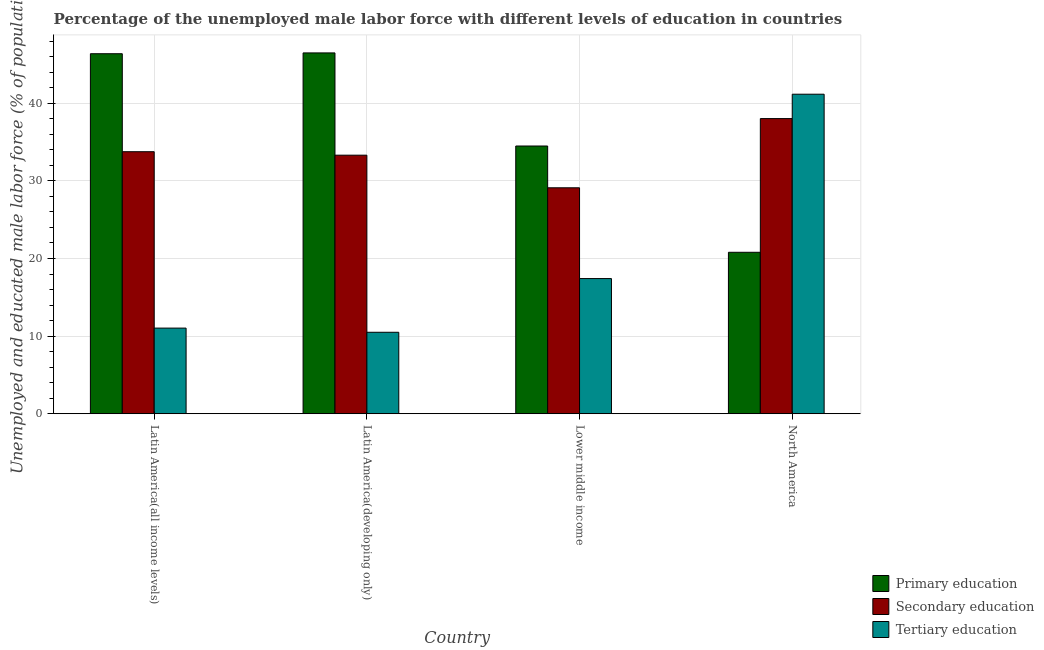How many different coloured bars are there?
Ensure brevity in your answer.  3. How many groups of bars are there?
Provide a succinct answer. 4. Are the number of bars per tick equal to the number of legend labels?
Ensure brevity in your answer.  Yes. Are the number of bars on each tick of the X-axis equal?
Keep it short and to the point. Yes. How many bars are there on the 4th tick from the left?
Make the answer very short. 3. What is the label of the 3rd group of bars from the left?
Keep it short and to the point. Lower middle income. In how many cases, is the number of bars for a given country not equal to the number of legend labels?
Your response must be concise. 0. What is the percentage of male labor force who received primary education in Latin America(all income levels)?
Provide a succinct answer. 46.39. Across all countries, what is the maximum percentage of male labor force who received primary education?
Ensure brevity in your answer.  46.49. Across all countries, what is the minimum percentage of male labor force who received primary education?
Make the answer very short. 20.8. In which country was the percentage of male labor force who received tertiary education maximum?
Your response must be concise. North America. In which country was the percentage of male labor force who received tertiary education minimum?
Your answer should be compact. Latin America(developing only). What is the total percentage of male labor force who received primary education in the graph?
Ensure brevity in your answer.  148.18. What is the difference between the percentage of male labor force who received primary education in Latin America(developing only) and that in Lower middle income?
Your answer should be compact. 11.99. What is the difference between the percentage of male labor force who received secondary education in Latin America(all income levels) and the percentage of male labor force who received tertiary education in Latin America(developing only)?
Your response must be concise. 23.26. What is the average percentage of male labor force who received primary education per country?
Provide a succinct answer. 37.04. What is the difference between the percentage of male labor force who received tertiary education and percentage of male labor force who received secondary education in Latin America(developing only)?
Offer a very short reply. -22.82. What is the ratio of the percentage of male labor force who received secondary education in Latin America(all income levels) to that in Lower middle income?
Give a very brief answer. 1.16. Is the percentage of male labor force who received secondary education in Latin America(developing only) less than that in North America?
Ensure brevity in your answer.  Yes. What is the difference between the highest and the second highest percentage of male labor force who received primary education?
Provide a short and direct response. 0.1. What is the difference between the highest and the lowest percentage of male labor force who received tertiary education?
Offer a terse response. 30.67. In how many countries, is the percentage of male labor force who received secondary education greater than the average percentage of male labor force who received secondary education taken over all countries?
Your answer should be compact. 2. Is the sum of the percentage of male labor force who received tertiary education in Latin America(all income levels) and Latin America(developing only) greater than the maximum percentage of male labor force who received secondary education across all countries?
Your response must be concise. No. What does the 2nd bar from the left in North America represents?
Offer a very short reply. Secondary education. What does the 1st bar from the right in Latin America(developing only) represents?
Provide a short and direct response. Tertiary education. Is it the case that in every country, the sum of the percentage of male labor force who received primary education and percentage of male labor force who received secondary education is greater than the percentage of male labor force who received tertiary education?
Your answer should be very brief. Yes. How many countries are there in the graph?
Offer a terse response. 4. What is the difference between two consecutive major ticks on the Y-axis?
Provide a short and direct response. 10. Does the graph contain any zero values?
Your answer should be very brief. No. Does the graph contain grids?
Offer a very short reply. Yes. Where does the legend appear in the graph?
Keep it short and to the point. Bottom right. How are the legend labels stacked?
Keep it short and to the point. Vertical. What is the title of the graph?
Make the answer very short. Percentage of the unemployed male labor force with different levels of education in countries. What is the label or title of the X-axis?
Offer a terse response. Country. What is the label or title of the Y-axis?
Make the answer very short. Unemployed and educated male labor force (% of population). What is the Unemployed and educated male labor force (% of population) of Primary education in Latin America(all income levels)?
Your answer should be very brief. 46.39. What is the Unemployed and educated male labor force (% of population) of Secondary education in Latin America(all income levels)?
Keep it short and to the point. 33.76. What is the Unemployed and educated male labor force (% of population) of Tertiary education in Latin America(all income levels)?
Give a very brief answer. 11.03. What is the Unemployed and educated male labor force (% of population) in Primary education in Latin America(developing only)?
Offer a terse response. 46.49. What is the Unemployed and educated male labor force (% of population) of Secondary education in Latin America(developing only)?
Offer a terse response. 33.31. What is the Unemployed and educated male labor force (% of population) of Tertiary education in Latin America(developing only)?
Provide a succinct answer. 10.5. What is the Unemployed and educated male labor force (% of population) in Primary education in Lower middle income?
Make the answer very short. 34.5. What is the Unemployed and educated male labor force (% of population) in Secondary education in Lower middle income?
Offer a very short reply. 29.11. What is the Unemployed and educated male labor force (% of population) in Tertiary education in Lower middle income?
Provide a succinct answer. 17.42. What is the Unemployed and educated male labor force (% of population) in Primary education in North America?
Your response must be concise. 20.8. What is the Unemployed and educated male labor force (% of population) of Secondary education in North America?
Your answer should be compact. 38.03. What is the Unemployed and educated male labor force (% of population) of Tertiary education in North America?
Give a very brief answer. 41.17. Across all countries, what is the maximum Unemployed and educated male labor force (% of population) of Primary education?
Ensure brevity in your answer.  46.49. Across all countries, what is the maximum Unemployed and educated male labor force (% of population) of Secondary education?
Provide a short and direct response. 38.03. Across all countries, what is the maximum Unemployed and educated male labor force (% of population) in Tertiary education?
Keep it short and to the point. 41.17. Across all countries, what is the minimum Unemployed and educated male labor force (% of population) in Primary education?
Provide a succinct answer. 20.8. Across all countries, what is the minimum Unemployed and educated male labor force (% of population) in Secondary education?
Provide a short and direct response. 29.11. Across all countries, what is the minimum Unemployed and educated male labor force (% of population) in Tertiary education?
Provide a succinct answer. 10.5. What is the total Unemployed and educated male labor force (% of population) of Primary education in the graph?
Give a very brief answer. 148.18. What is the total Unemployed and educated male labor force (% of population) of Secondary education in the graph?
Give a very brief answer. 134.22. What is the total Unemployed and educated male labor force (% of population) of Tertiary education in the graph?
Your answer should be compact. 80.12. What is the difference between the Unemployed and educated male labor force (% of population) of Primary education in Latin America(all income levels) and that in Latin America(developing only)?
Ensure brevity in your answer.  -0.1. What is the difference between the Unemployed and educated male labor force (% of population) of Secondary education in Latin America(all income levels) and that in Latin America(developing only)?
Provide a succinct answer. 0.45. What is the difference between the Unemployed and educated male labor force (% of population) of Tertiary education in Latin America(all income levels) and that in Latin America(developing only)?
Offer a terse response. 0.54. What is the difference between the Unemployed and educated male labor force (% of population) of Primary education in Latin America(all income levels) and that in Lower middle income?
Give a very brief answer. 11.89. What is the difference between the Unemployed and educated male labor force (% of population) in Secondary education in Latin America(all income levels) and that in Lower middle income?
Keep it short and to the point. 4.65. What is the difference between the Unemployed and educated male labor force (% of population) of Tertiary education in Latin America(all income levels) and that in Lower middle income?
Your response must be concise. -6.38. What is the difference between the Unemployed and educated male labor force (% of population) of Primary education in Latin America(all income levels) and that in North America?
Your answer should be very brief. 25.58. What is the difference between the Unemployed and educated male labor force (% of population) in Secondary education in Latin America(all income levels) and that in North America?
Offer a very short reply. -4.27. What is the difference between the Unemployed and educated male labor force (% of population) in Tertiary education in Latin America(all income levels) and that in North America?
Offer a terse response. -30.13. What is the difference between the Unemployed and educated male labor force (% of population) in Primary education in Latin America(developing only) and that in Lower middle income?
Offer a terse response. 11.99. What is the difference between the Unemployed and educated male labor force (% of population) of Secondary education in Latin America(developing only) and that in Lower middle income?
Keep it short and to the point. 4.2. What is the difference between the Unemployed and educated male labor force (% of population) in Tertiary education in Latin America(developing only) and that in Lower middle income?
Ensure brevity in your answer.  -6.92. What is the difference between the Unemployed and educated male labor force (% of population) of Primary education in Latin America(developing only) and that in North America?
Provide a short and direct response. 25.69. What is the difference between the Unemployed and educated male labor force (% of population) in Secondary education in Latin America(developing only) and that in North America?
Make the answer very short. -4.71. What is the difference between the Unemployed and educated male labor force (% of population) of Tertiary education in Latin America(developing only) and that in North America?
Your answer should be very brief. -30.67. What is the difference between the Unemployed and educated male labor force (% of population) in Primary education in Lower middle income and that in North America?
Your answer should be compact. 13.69. What is the difference between the Unemployed and educated male labor force (% of population) in Secondary education in Lower middle income and that in North America?
Your answer should be very brief. -8.92. What is the difference between the Unemployed and educated male labor force (% of population) in Tertiary education in Lower middle income and that in North America?
Provide a short and direct response. -23.75. What is the difference between the Unemployed and educated male labor force (% of population) of Primary education in Latin America(all income levels) and the Unemployed and educated male labor force (% of population) of Secondary education in Latin America(developing only)?
Offer a terse response. 13.07. What is the difference between the Unemployed and educated male labor force (% of population) of Primary education in Latin America(all income levels) and the Unemployed and educated male labor force (% of population) of Tertiary education in Latin America(developing only)?
Your answer should be very brief. 35.89. What is the difference between the Unemployed and educated male labor force (% of population) in Secondary education in Latin America(all income levels) and the Unemployed and educated male labor force (% of population) in Tertiary education in Latin America(developing only)?
Keep it short and to the point. 23.26. What is the difference between the Unemployed and educated male labor force (% of population) in Primary education in Latin America(all income levels) and the Unemployed and educated male labor force (% of population) in Secondary education in Lower middle income?
Give a very brief answer. 17.27. What is the difference between the Unemployed and educated male labor force (% of population) of Primary education in Latin America(all income levels) and the Unemployed and educated male labor force (% of population) of Tertiary education in Lower middle income?
Your response must be concise. 28.97. What is the difference between the Unemployed and educated male labor force (% of population) of Secondary education in Latin America(all income levels) and the Unemployed and educated male labor force (% of population) of Tertiary education in Lower middle income?
Make the answer very short. 16.34. What is the difference between the Unemployed and educated male labor force (% of population) in Primary education in Latin America(all income levels) and the Unemployed and educated male labor force (% of population) in Secondary education in North America?
Your answer should be very brief. 8.36. What is the difference between the Unemployed and educated male labor force (% of population) of Primary education in Latin America(all income levels) and the Unemployed and educated male labor force (% of population) of Tertiary education in North America?
Offer a terse response. 5.22. What is the difference between the Unemployed and educated male labor force (% of population) of Secondary education in Latin America(all income levels) and the Unemployed and educated male labor force (% of population) of Tertiary education in North America?
Make the answer very short. -7.41. What is the difference between the Unemployed and educated male labor force (% of population) in Primary education in Latin America(developing only) and the Unemployed and educated male labor force (% of population) in Secondary education in Lower middle income?
Provide a succinct answer. 17.38. What is the difference between the Unemployed and educated male labor force (% of population) of Primary education in Latin America(developing only) and the Unemployed and educated male labor force (% of population) of Tertiary education in Lower middle income?
Provide a succinct answer. 29.07. What is the difference between the Unemployed and educated male labor force (% of population) in Secondary education in Latin America(developing only) and the Unemployed and educated male labor force (% of population) in Tertiary education in Lower middle income?
Give a very brief answer. 15.9. What is the difference between the Unemployed and educated male labor force (% of population) of Primary education in Latin America(developing only) and the Unemployed and educated male labor force (% of population) of Secondary education in North America?
Provide a succinct answer. 8.46. What is the difference between the Unemployed and educated male labor force (% of population) of Primary education in Latin America(developing only) and the Unemployed and educated male labor force (% of population) of Tertiary education in North America?
Provide a short and direct response. 5.32. What is the difference between the Unemployed and educated male labor force (% of population) in Secondary education in Latin America(developing only) and the Unemployed and educated male labor force (% of population) in Tertiary education in North America?
Offer a very short reply. -7.85. What is the difference between the Unemployed and educated male labor force (% of population) in Primary education in Lower middle income and the Unemployed and educated male labor force (% of population) in Secondary education in North America?
Make the answer very short. -3.53. What is the difference between the Unemployed and educated male labor force (% of population) of Primary education in Lower middle income and the Unemployed and educated male labor force (% of population) of Tertiary education in North America?
Provide a short and direct response. -6.67. What is the difference between the Unemployed and educated male labor force (% of population) of Secondary education in Lower middle income and the Unemployed and educated male labor force (% of population) of Tertiary education in North America?
Make the answer very short. -12.06. What is the average Unemployed and educated male labor force (% of population) of Primary education per country?
Offer a very short reply. 37.04. What is the average Unemployed and educated male labor force (% of population) of Secondary education per country?
Offer a terse response. 33.55. What is the average Unemployed and educated male labor force (% of population) in Tertiary education per country?
Give a very brief answer. 20.03. What is the difference between the Unemployed and educated male labor force (% of population) of Primary education and Unemployed and educated male labor force (% of population) of Secondary education in Latin America(all income levels)?
Give a very brief answer. 12.63. What is the difference between the Unemployed and educated male labor force (% of population) of Primary education and Unemployed and educated male labor force (% of population) of Tertiary education in Latin America(all income levels)?
Make the answer very short. 35.35. What is the difference between the Unemployed and educated male labor force (% of population) of Secondary education and Unemployed and educated male labor force (% of population) of Tertiary education in Latin America(all income levels)?
Give a very brief answer. 22.73. What is the difference between the Unemployed and educated male labor force (% of population) of Primary education and Unemployed and educated male labor force (% of population) of Secondary education in Latin America(developing only)?
Offer a very short reply. 13.18. What is the difference between the Unemployed and educated male labor force (% of population) of Primary education and Unemployed and educated male labor force (% of population) of Tertiary education in Latin America(developing only)?
Offer a very short reply. 35.99. What is the difference between the Unemployed and educated male labor force (% of population) in Secondary education and Unemployed and educated male labor force (% of population) in Tertiary education in Latin America(developing only)?
Provide a short and direct response. 22.82. What is the difference between the Unemployed and educated male labor force (% of population) of Primary education and Unemployed and educated male labor force (% of population) of Secondary education in Lower middle income?
Keep it short and to the point. 5.38. What is the difference between the Unemployed and educated male labor force (% of population) in Primary education and Unemployed and educated male labor force (% of population) in Tertiary education in Lower middle income?
Ensure brevity in your answer.  17.08. What is the difference between the Unemployed and educated male labor force (% of population) in Secondary education and Unemployed and educated male labor force (% of population) in Tertiary education in Lower middle income?
Provide a succinct answer. 11.7. What is the difference between the Unemployed and educated male labor force (% of population) of Primary education and Unemployed and educated male labor force (% of population) of Secondary education in North America?
Keep it short and to the point. -17.23. What is the difference between the Unemployed and educated male labor force (% of population) of Primary education and Unemployed and educated male labor force (% of population) of Tertiary education in North America?
Offer a terse response. -20.37. What is the difference between the Unemployed and educated male labor force (% of population) in Secondary education and Unemployed and educated male labor force (% of population) in Tertiary education in North America?
Your response must be concise. -3.14. What is the ratio of the Unemployed and educated male labor force (% of population) in Secondary education in Latin America(all income levels) to that in Latin America(developing only)?
Offer a terse response. 1.01. What is the ratio of the Unemployed and educated male labor force (% of population) of Tertiary education in Latin America(all income levels) to that in Latin America(developing only)?
Your answer should be compact. 1.05. What is the ratio of the Unemployed and educated male labor force (% of population) of Primary education in Latin America(all income levels) to that in Lower middle income?
Your response must be concise. 1.34. What is the ratio of the Unemployed and educated male labor force (% of population) in Secondary education in Latin America(all income levels) to that in Lower middle income?
Your response must be concise. 1.16. What is the ratio of the Unemployed and educated male labor force (% of population) in Tertiary education in Latin America(all income levels) to that in Lower middle income?
Give a very brief answer. 0.63. What is the ratio of the Unemployed and educated male labor force (% of population) of Primary education in Latin America(all income levels) to that in North America?
Provide a short and direct response. 2.23. What is the ratio of the Unemployed and educated male labor force (% of population) of Secondary education in Latin America(all income levels) to that in North America?
Your response must be concise. 0.89. What is the ratio of the Unemployed and educated male labor force (% of population) of Tertiary education in Latin America(all income levels) to that in North America?
Provide a succinct answer. 0.27. What is the ratio of the Unemployed and educated male labor force (% of population) in Primary education in Latin America(developing only) to that in Lower middle income?
Make the answer very short. 1.35. What is the ratio of the Unemployed and educated male labor force (% of population) in Secondary education in Latin America(developing only) to that in Lower middle income?
Offer a very short reply. 1.14. What is the ratio of the Unemployed and educated male labor force (% of population) in Tertiary education in Latin America(developing only) to that in Lower middle income?
Keep it short and to the point. 0.6. What is the ratio of the Unemployed and educated male labor force (% of population) of Primary education in Latin America(developing only) to that in North America?
Keep it short and to the point. 2.23. What is the ratio of the Unemployed and educated male labor force (% of population) in Secondary education in Latin America(developing only) to that in North America?
Provide a short and direct response. 0.88. What is the ratio of the Unemployed and educated male labor force (% of population) of Tertiary education in Latin America(developing only) to that in North America?
Keep it short and to the point. 0.26. What is the ratio of the Unemployed and educated male labor force (% of population) in Primary education in Lower middle income to that in North America?
Your answer should be very brief. 1.66. What is the ratio of the Unemployed and educated male labor force (% of population) of Secondary education in Lower middle income to that in North America?
Keep it short and to the point. 0.77. What is the ratio of the Unemployed and educated male labor force (% of population) of Tertiary education in Lower middle income to that in North America?
Provide a short and direct response. 0.42. What is the difference between the highest and the second highest Unemployed and educated male labor force (% of population) of Primary education?
Your response must be concise. 0.1. What is the difference between the highest and the second highest Unemployed and educated male labor force (% of population) in Secondary education?
Keep it short and to the point. 4.27. What is the difference between the highest and the second highest Unemployed and educated male labor force (% of population) of Tertiary education?
Offer a terse response. 23.75. What is the difference between the highest and the lowest Unemployed and educated male labor force (% of population) in Primary education?
Provide a short and direct response. 25.69. What is the difference between the highest and the lowest Unemployed and educated male labor force (% of population) of Secondary education?
Keep it short and to the point. 8.92. What is the difference between the highest and the lowest Unemployed and educated male labor force (% of population) in Tertiary education?
Your response must be concise. 30.67. 